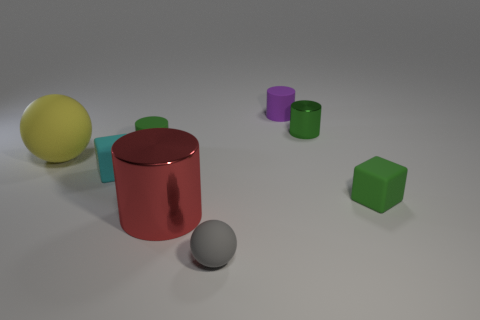Subtract all small cylinders. How many cylinders are left? 1 Subtract all purple cylinders. How many cylinders are left? 3 Add 2 big green balls. How many objects exist? 10 Subtract all gray cylinders. Subtract all purple balls. How many cylinders are left? 4 Subtract 0 yellow blocks. How many objects are left? 8 Subtract all blocks. How many objects are left? 6 Subtract all cylinders. Subtract all small red cylinders. How many objects are left? 4 Add 7 yellow things. How many yellow things are left? 8 Add 1 shiny balls. How many shiny balls exist? 1 